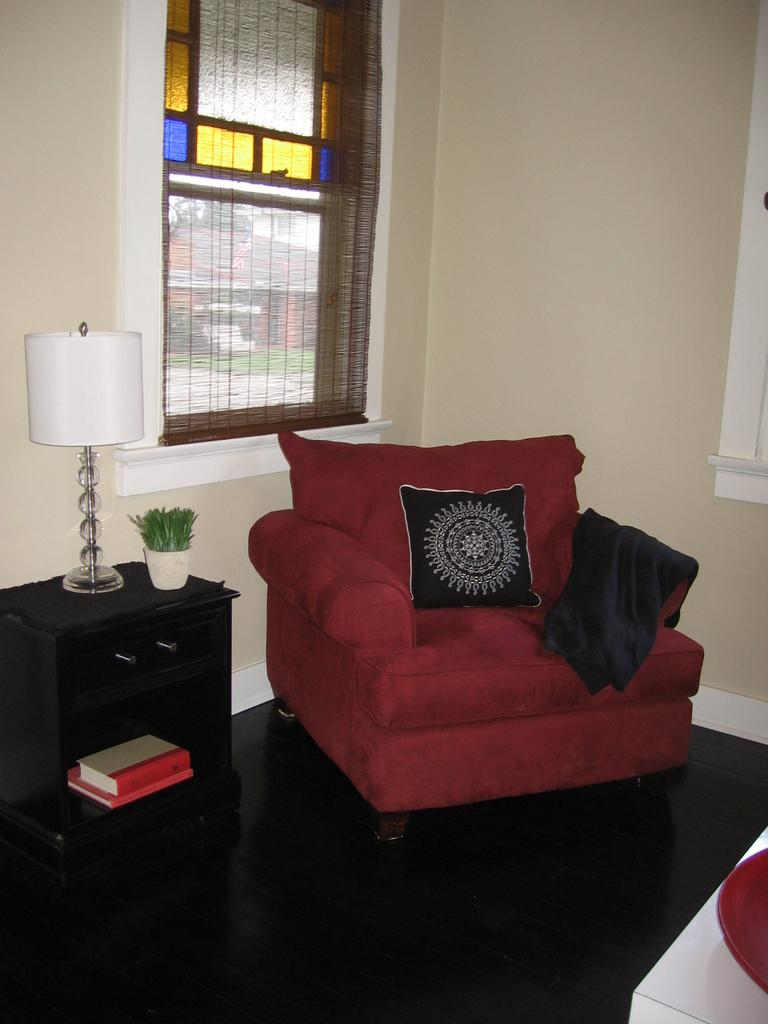What type of furniture is in the image? There is a sofa in the image. What is located beside the sofa? There is a table beside the sofa. What is placed on the table? A lamp is placed on the table. What can be seen in the background of the image? There is a window and a wall in the background of the image. Can you see a stream flowing through the room in the image? There is no stream visible in the image; it features a sofa, table, lamp, window, and wall. 